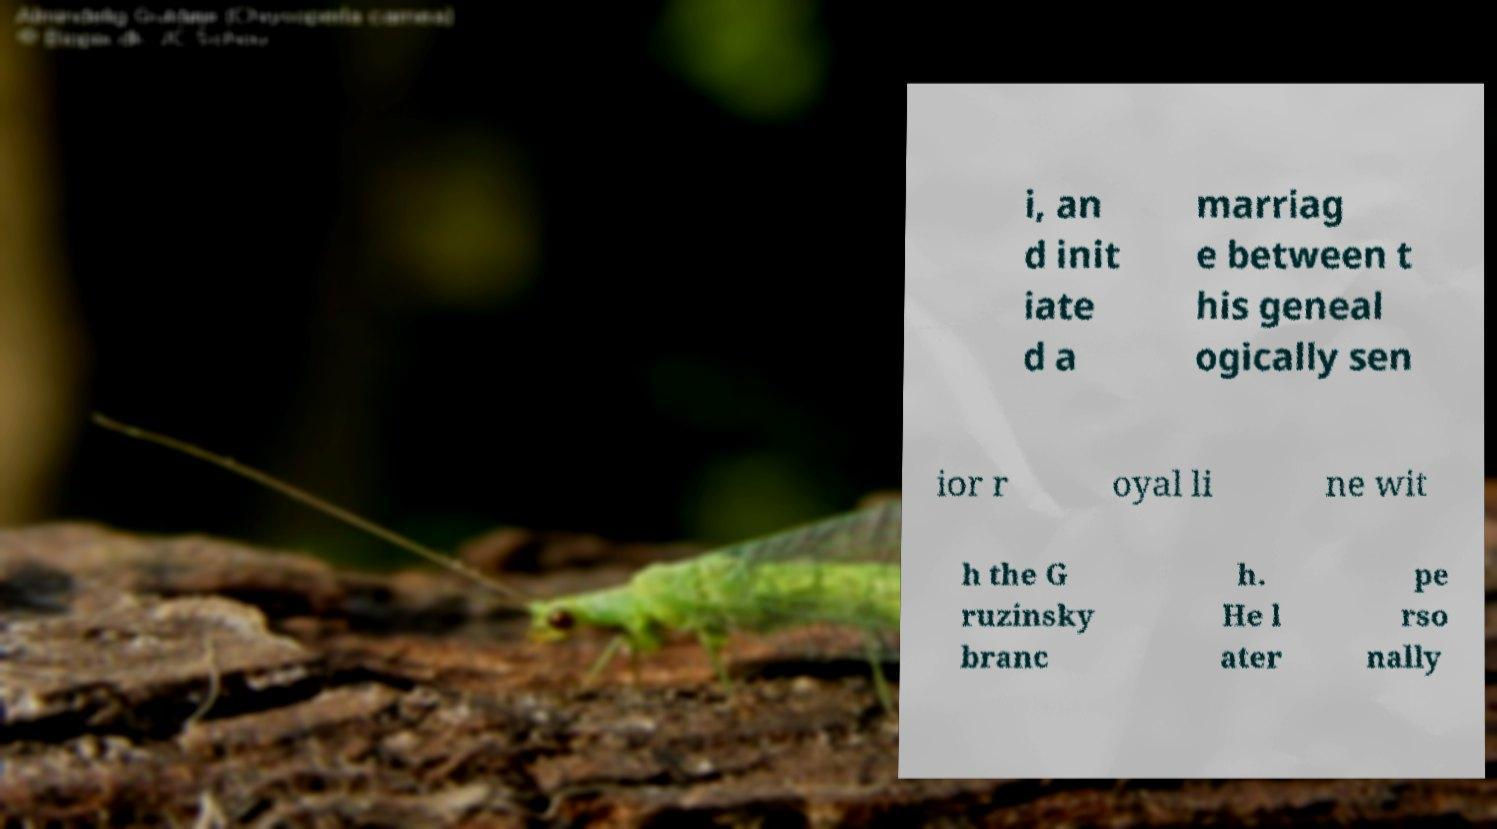Could you extract and type out the text from this image? i, an d init iate d a marriag e between t his geneal ogically sen ior r oyal li ne wit h the G ruzinsky branc h. He l ater pe rso nally 